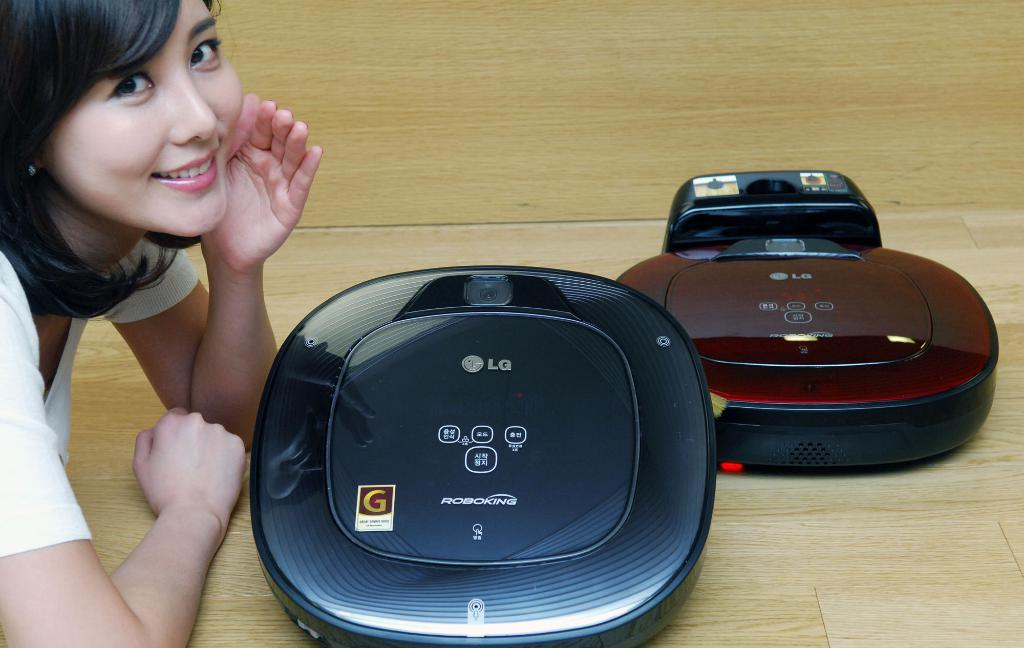<image>
Relay a brief, clear account of the picture shown. Two  Roboking devices that have the LG logo on the front. 